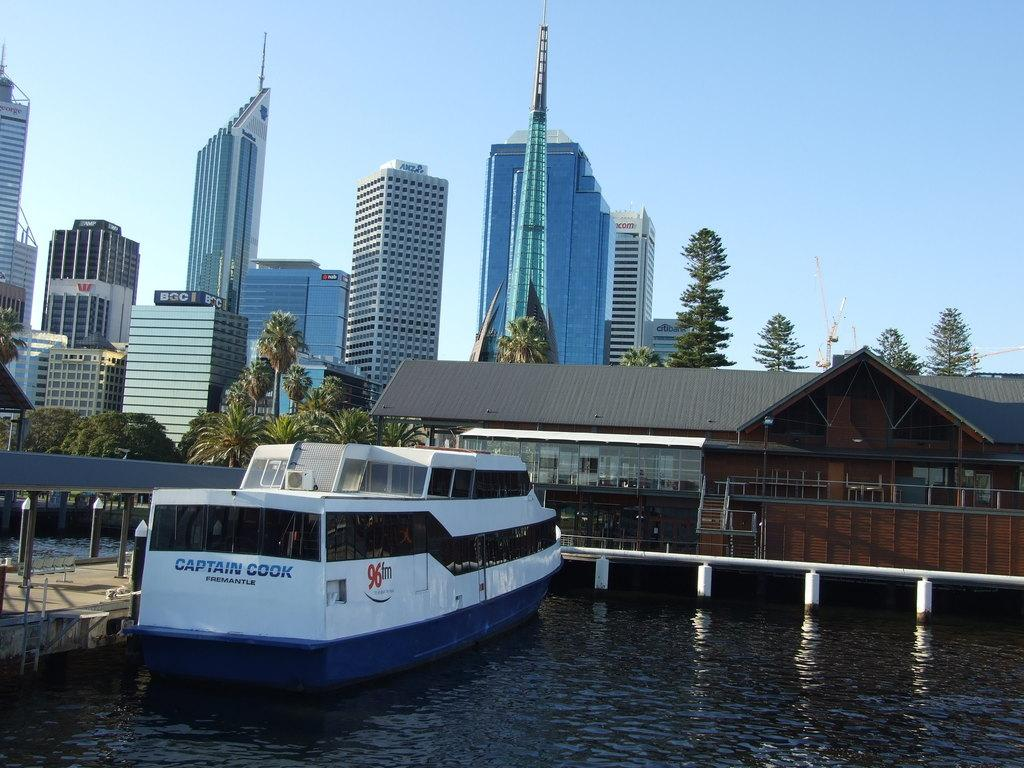What is the primary element in the image? There is water in the image. What type of structure can be seen in the image? There is a wooden bridge in the image. Can you describe the ship in the image? The ship in the image is white and blue in color. What can be seen in the background of the image? There are buildings, trees, cranes, and the sky visible in the background of the image. How many toothbrushes are hanging on the trees in the image? There are no toothbrushes present in the image; it features a wooden bridge, a ship, and various elements in the background. What time is displayed on the clock in the image? There is no clock present in the image. 